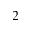<formula> <loc_0><loc_0><loc_500><loc_500>^ { 2 }</formula> 